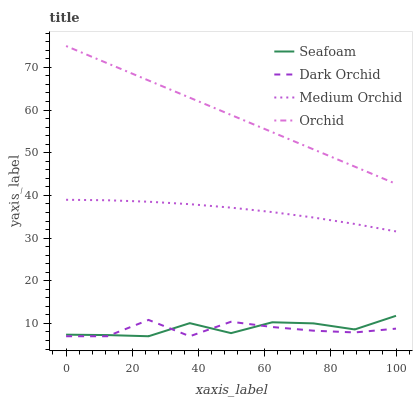Does Dark Orchid have the minimum area under the curve?
Answer yes or no. Yes. Does Orchid have the maximum area under the curve?
Answer yes or no. Yes. Does Seafoam have the minimum area under the curve?
Answer yes or no. No. Does Seafoam have the maximum area under the curve?
Answer yes or no. No. Is Orchid the smoothest?
Answer yes or no. Yes. Is Dark Orchid the roughest?
Answer yes or no. Yes. Is Seafoam the smoothest?
Answer yes or no. No. Is Seafoam the roughest?
Answer yes or no. No. Does Seafoam have the lowest value?
Answer yes or no. Yes. Does Orchid have the lowest value?
Answer yes or no. No. Does Orchid have the highest value?
Answer yes or no. Yes. Does Seafoam have the highest value?
Answer yes or no. No. Is Dark Orchid less than Orchid?
Answer yes or no. Yes. Is Medium Orchid greater than Seafoam?
Answer yes or no. Yes. Does Seafoam intersect Dark Orchid?
Answer yes or no. Yes. Is Seafoam less than Dark Orchid?
Answer yes or no. No. Is Seafoam greater than Dark Orchid?
Answer yes or no. No. Does Dark Orchid intersect Orchid?
Answer yes or no. No. 